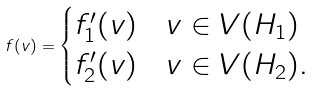Convert formula to latex. <formula><loc_0><loc_0><loc_500><loc_500>f ( v ) = \begin{cases} f ^ { \prime } _ { 1 } ( v ) & v \in V ( H _ { 1 } ) \\ f ^ { \prime } _ { 2 } ( v ) & v \in V ( H _ { 2 } ) . \end{cases}</formula> 